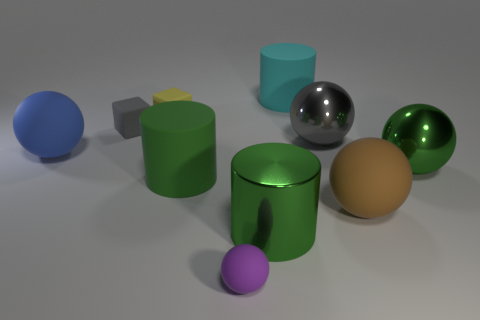What is the material of the sphere that is the same color as the big metallic cylinder?
Your response must be concise. Metal. What size is the cyan cylinder?
Ensure brevity in your answer.  Large. How many cyan cylinders are the same size as the yellow matte object?
Your answer should be compact. 0. Do the metallic thing behind the blue sphere and the ball that is in front of the brown rubber sphere have the same size?
Keep it short and to the point. No. What shape is the small rubber object behind the small gray matte thing?
Ensure brevity in your answer.  Cube. There is a green thing that is on the right side of the cylinder behind the big green shiny ball; what is its material?
Ensure brevity in your answer.  Metal. Are there any matte objects of the same color as the small sphere?
Give a very brief answer. No. Does the cyan cylinder have the same size as the yellow thing that is in front of the cyan matte cylinder?
Offer a very short reply. No. What number of gray blocks are behind the big rubber sphere that is in front of the cylinder that is to the left of the small rubber sphere?
Keep it short and to the point. 1. There is a gray metal thing; how many metal things are to the left of it?
Your response must be concise. 1. 